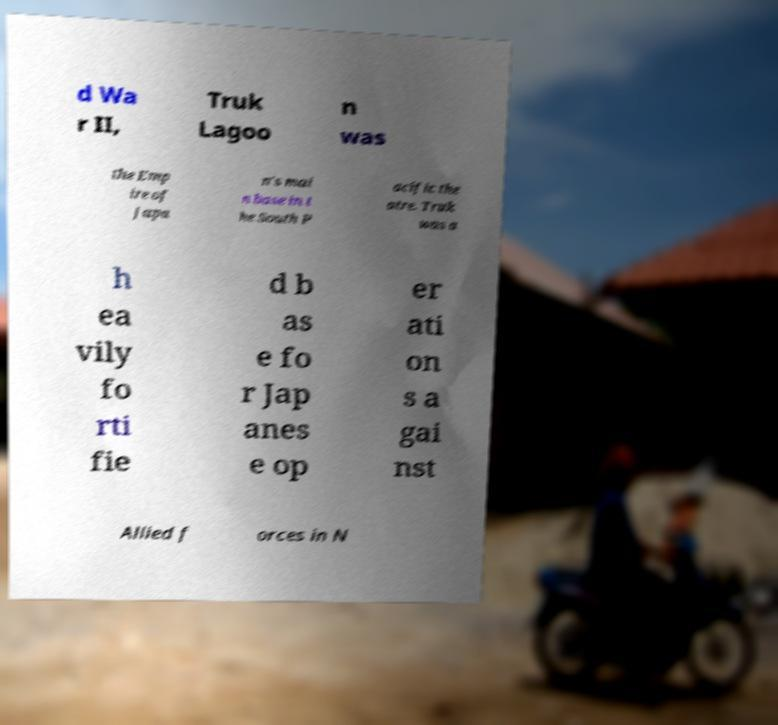Could you assist in decoding the text presented in this image and type it out clearly? d Wa r II, Truk Lagoo n was the Emp ire of Japa n's mai n base in t he South P acific the atre. Truk was a h ea vily fo rti fie d b as e fo r Jap anes e op er ati on s a gai nst Allied f orces in N 